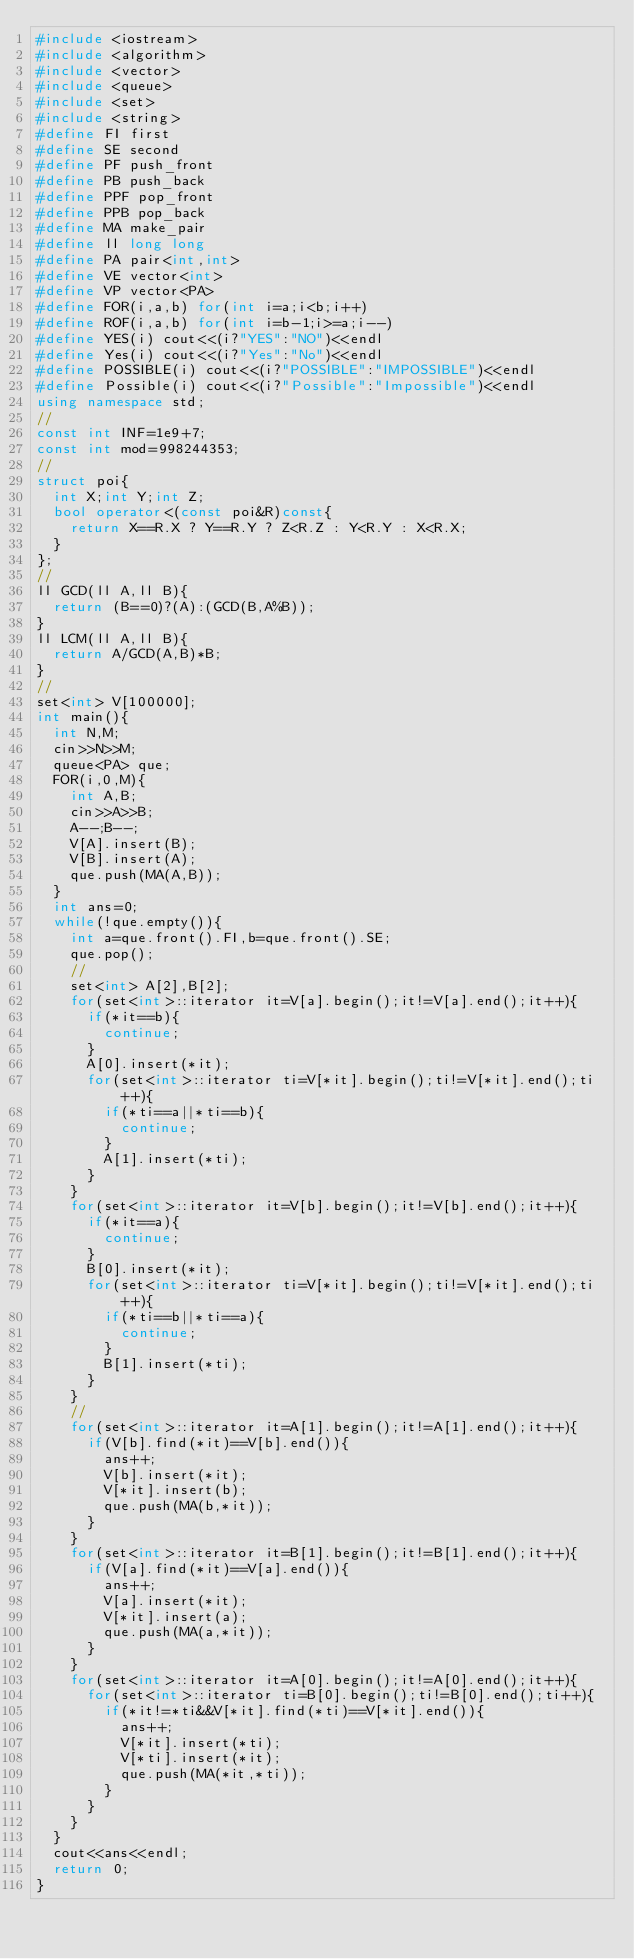Convert code to text. <code><loc_0><loc_0><loc_500><loc_500><_C++_>#include <iostream>
#include <algorithm>
#include <vector>
#include <queue>
#include <set>
#include <string>
#define FI first
#define SE second
#define PF push_front
#define PB push_back
#define PPF pop_front
#define PPB pop_back
#define MA make_pair
#define ll long long
#define PA pair<int,int>
#define VE vector<int>
#define VP vector<PA>
#define FOR(i,a,b) for(int i=a;i<b;i++)
#define ROF(i,a,b) for(int i=b-1;i>=a;i--)
#define YES(i) cout<<(i?"YES":"NO")<<endl
#define Yes(i) cout<<(i?"Yes":"No")<<endl
#define POSSIBLE(i) cout<<(i?"POSSIBLE":"IMPOSSIBLE")<<endl
#define Possible(i) cout<<(i?"Possible":"Impossible")<<endl
using namespace std;
//
const int INF=1e9+7;
const int mod=998244353;
//
struct poi{
	int X;int Y;int Z;
	bool operator<(const poi&R)const{
		return X==R.X ? Y==R.Y ? Z<R.Z : Y<R.Y : X<R.X;
	}
};
//
ll GCD(ll A,ll B){
  return (B==0)?(A):(GCD(B,A%B));
}
ll LCM(ll A,ll B){
  return A/GCD(A,B)*B;
}
//
set<int> V[100000];
int main(){
	int N,M;
	cin>>N>>M;
	queue<PA> que;
	FOR(i,0,M){
		int A,B;
		cin>>A>>B;
		A--;B--;
		V[A].insert(B);
		V[B].insert(A);
		que.push(MA(A,B));
	}
	int ans=0;
	while(!que.empty()){
		int a=que.front().FI,b=que.front().SE;
		que.pop();
		//
		set<int> A[2],B[2];
		for(set<int>::iterator it=V[a].begin();it!=V[a].end();it++){
			if(*it==b){
				continue;
			}
			A[0].insert(*it);
			for(set<int>::iterator ti=V[*it].begin();ti!=V[*it].end();ti++){
				if(*ti==a||*ti==b){
					continue;
				}
				A[1].insert(*ti);
			}
		}
		for(set<int>::iterator it=V[b].begin();it!=V[b].end();it++){
			if(*it==a){
				continue;
			}
			B[0].insert(*it);
			for(set<int>::iterator ti=V[*it].begin();ti!=V[*it].end();ti++){
				if(*ti==b||*ti==a){
					continue;
				}
				B[1].insert(*ti);
			}
		}
		//
		for(set<int>::iterator it=A[1].begin();it!=A[1].end();it++){
			if(V[b].find(*it)==V[b].end()){
				ans++;
				V[b].insert(*it);
				V[*it].insert(b);
				que.push(MA(b,*it));
			}
		}
		for(set<int>::iterator it=B[1].begin();it!=B[1].end();it++){
			if(V[a].find(*it)==V[a].end()){
				ans++;
				V[a].insert(*it);
				V[*it].insert(a);
				que.push(MA(a,*it));
			}
		}
		for(set<int>::iterator it=A[0].begin();it!=A[0].end();it++){
			for(set<int>::iterator ti=B[0].begin();ti!=B[0].end();ti++){
				if(*it!=*ti&&V[*it].find(*ti)==V[*it].end()){
					ans++;
					V[*it].insert(*ti);
					V[*ti].insert(*it);
					que.push(MA(*it,*ti));
				}
			}
		}
	}
	cout<<ans<<endl;
	return 0;
}</code> 